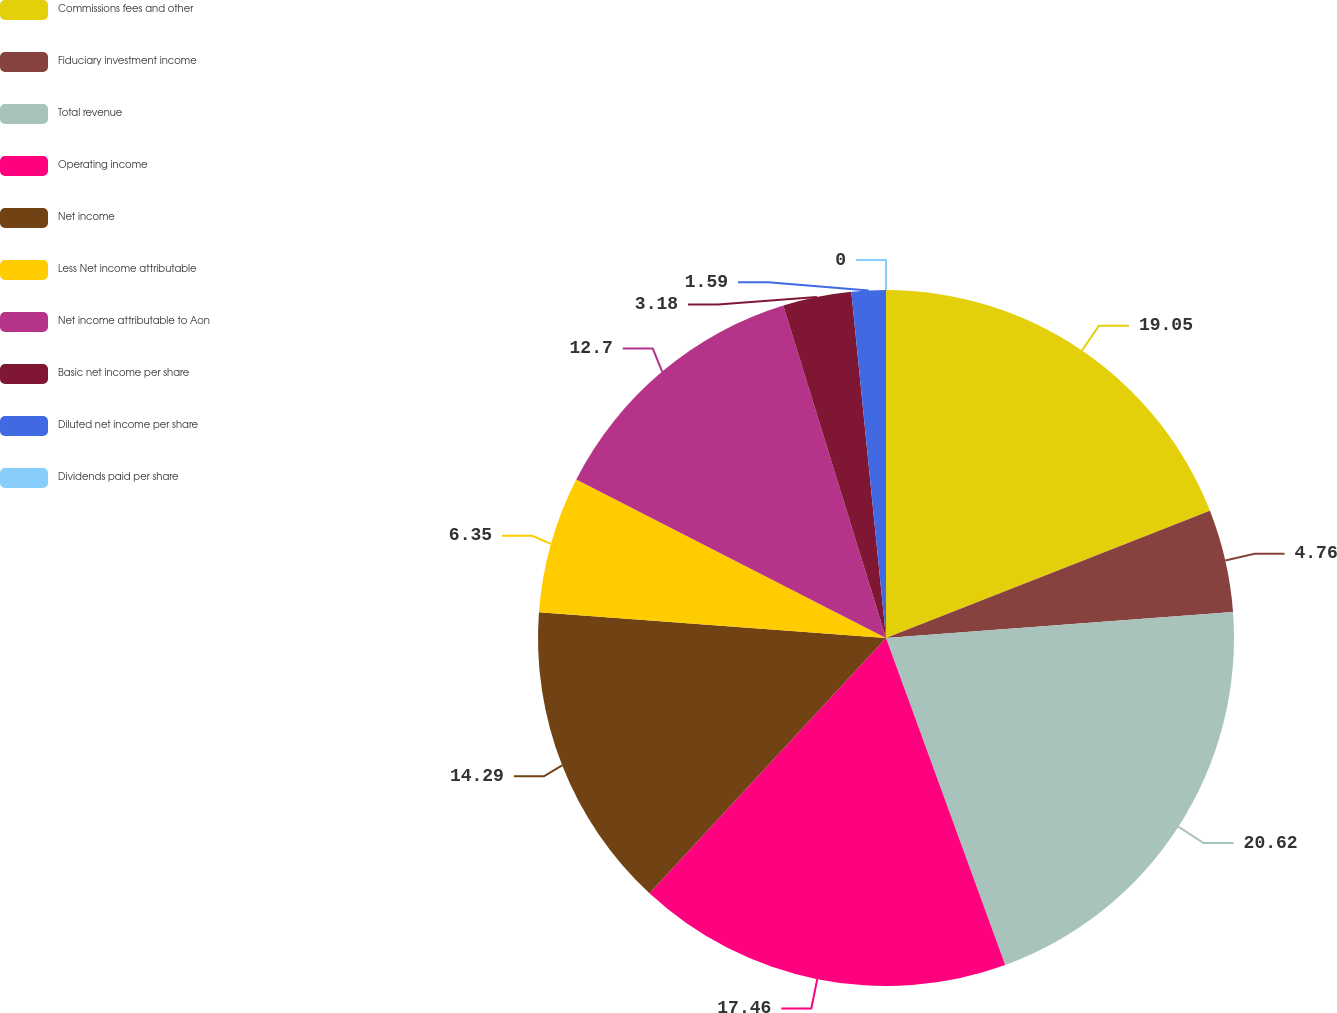Convert chart. <chart><loc_0><loc_0><loc_500><loc_500><pie_chart><fcel>Commissions fees and other<fcel>Fiduciary investment income<fcel>Total revenue<fcel>Operating income<fcel>Net income<fcel>Less Net income attributable<fcel>Net income attributable to Aon<fcel>Basic net income per share<fcel>Diluted net income per share<fcel>Dividends paid per share<nl><fcel>19.05%<fcel>4.76%<fcel>20.63%<fcel>17.46%<fcel>14.29%<fcel>6.35%<fcel>12.7%<fcel>3.18%<fcel>1.59%<fcel>0.0%<nl></chart> 